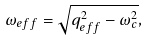Convert formula to latex. <formula><loc_0><loc_0><loc_500><loc_500>\omega _ { e f f } = \sqrt { q ^ { 2 } _ { e f f } - \omega ^ { 2 } _ { c } } ,</formula> 